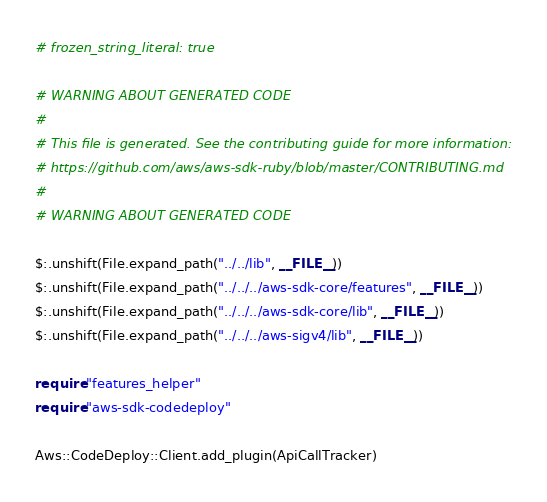<code> <loc_0><loc_0><loc_500><loc_500><_Crystal_># frozen_string_literal: true

# WARNING ABOUT GENERATED CODE
#
# This file is generated. See the contributing guide for more information:
# https://github.com/aws/aws-sdk-ruby/blob/master/CONTRIBUTING.md
#
# WARNING ABOUT GENERATED CODE

$:.unshift(File.expand_path("../../lib", __FILE__))
$:.unshift(File.expand_path("../../../aws-sdk-core/features", __FILE__))
$:.unshift(File.expand_path("../../../aws-sdk-core/lib", __FILE__))
$:.unshift(File.expand_path("../../../aws-sigv4/lib", __FILE__))

require "features_helper"
require "aws-sdk-codedeploy"

Aws::CodeDeploy::Client.add_plugin(ApiCallTracker)
</code> 